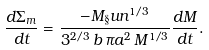<formula> <loc_0><loc_0><loc_500><loc_500>\frac { d \Sigma _ { m } } { d t } = \frac { - M _ { \S } u n ^ { 1 / 3 } } { 3 ^ { 2 / 3 } \, b \, \pi a ^ { 2 } \, M ^ { 1 / 3 } } \frac { d M } { d t } .</formula> 